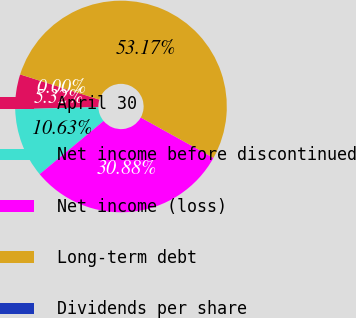Convert chart to OTSL. <chart><loc_0><loc_0><loc_500><loc_500><pie_chart><fcel>April 30<fcel>Net income before discontinued<fcel>Net income (loss)<fcel>Long-term debt<fcel>Dividends per share<nl><fcel>5.32%<fcel>10.63%<fcel>30.88%<fcel>53.17%<fcel>0.0%<nl></chart> 